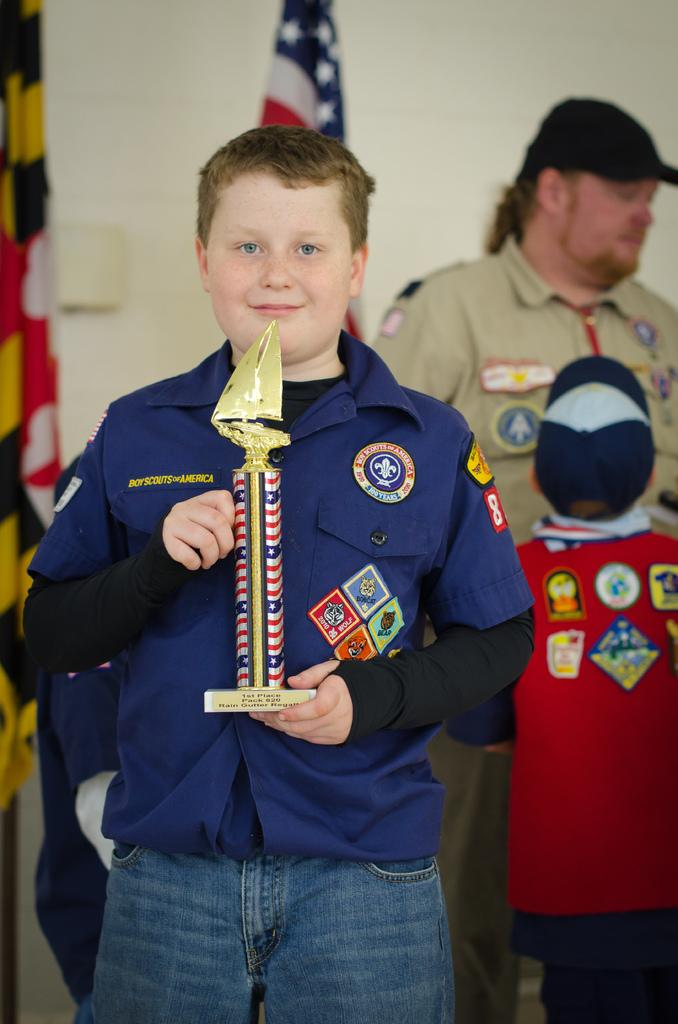Who is the main subject in the image? There is a boy in the image. What is the boy holding in his hands? The boy is holding a memento in his hands. What can be seen at the top of the image? There is a flag visible at the top of the image. How many people are standing on the right side of the image? There are two people standing on the right side of the image. What type of action is the toad performing in the image? There is no toad present in the image, so no such action can be observed. 